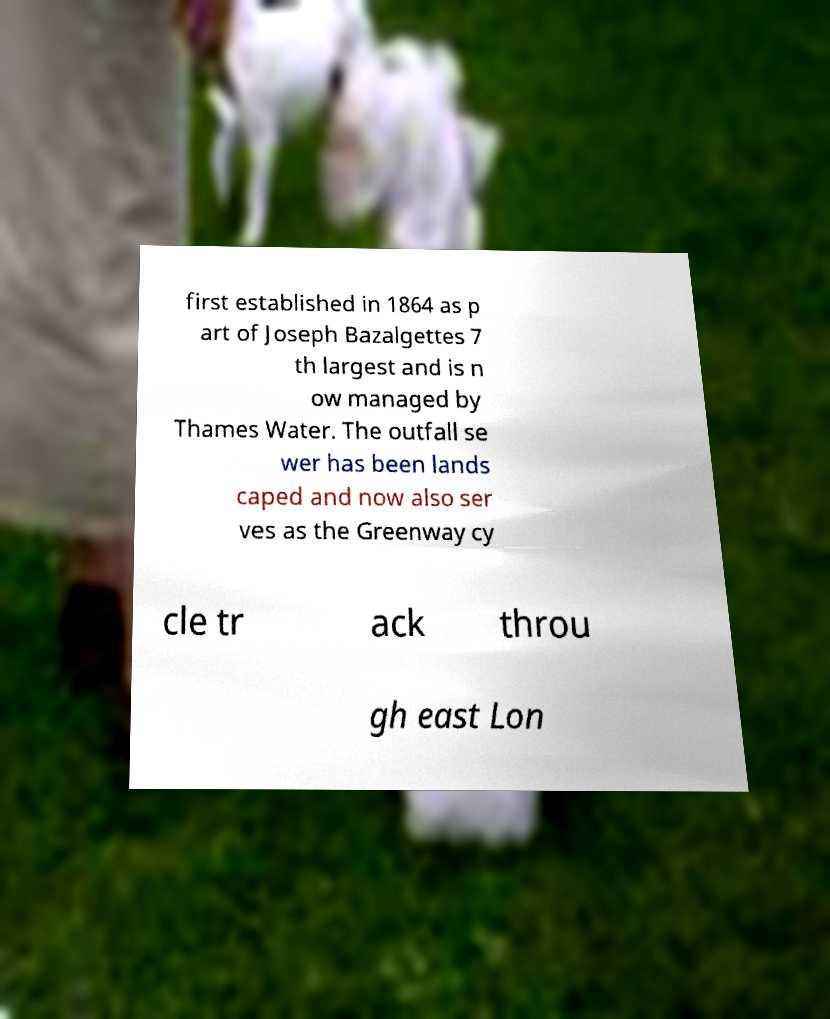What messages or text are displayed in this image? I need them in a readable, typed format. first established in 1864 as p art of Joseph Bazalgettes 7 th largest and is n ow managed by Thames Water. The outfall se wer has been lands caped and now also ser ves as the Greenway cy cle tr ack throu gh east Lon 